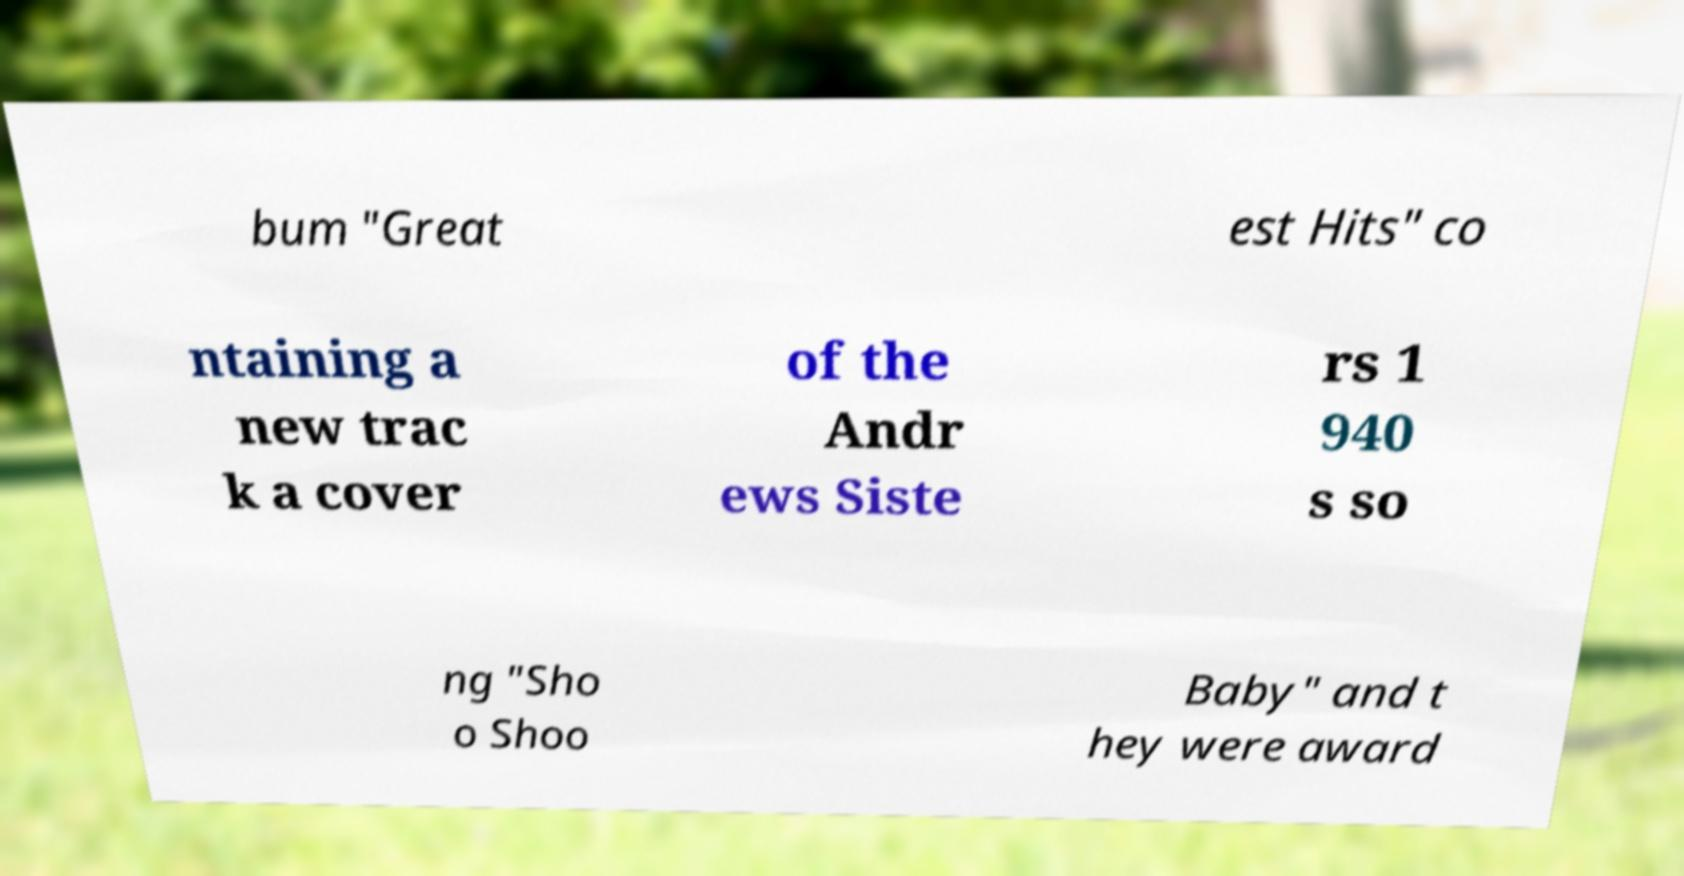There's text embedded in this image that I need extracted. Can you transcribe it verbatim? bum "Great est Hits" co ntaining a new trac k a cover of the Andr ews Siste rs 1 940 s so ng "Sho o Shoo Baby" and t hey were award 